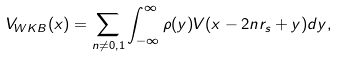Convert formula to latex. <formula><loc_0><loc_0><loc_500><loc_500>V _ { W K B } ( x ) = \sum _ { n \neq 0 , 1 } \int _ { - \infty } ^ { \infty } \rho ( y ) V ( x - 2 n r _ { s } + y ) d y ,</formula> 